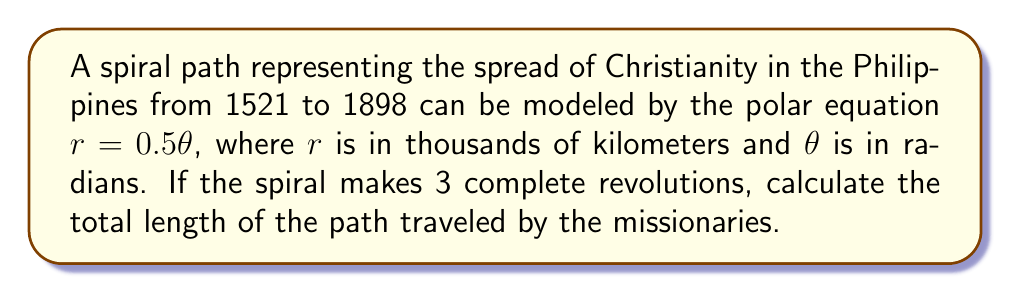Can you solve this math problem? To solve this problem, we'll follow these steps:

1) First, recall the formula for the arc length of a curve in polar coordinates:

   $$L = \int_a^b \sqrt{r^2 + \left(\frac{dr}{d\theta}\right)^2} d\theta$$

2) For our spiral, $r = 0.5\theta$, so $\frac{dr}{d\theta} = 0.5$

3) Substituting these into the formula:

   $$L = \int_a^b \sqrt{(0.5\theta)^2 + (0.5)^2} d\theta$$

4) Simplify under the square root:

   $$L = \int_a^b \sqrt{0.25\theta^2 + 0.25} d\theta = 0.5\int_a^b \sqrt{\theta^2 + 1} d\theta$$

5) For the limits of integration, we start at $\theta = 0$ and end at $\theta = 6\pi$ (3 complete revolutions)

6) This integral doesn't have an elementary antiderivative, but it can be solved using the hyperbolic sine function:

   $$L = 0.5 \left[\frac{\theta}{2}\sqrt{\theta^2+1} + \frac{1}{2}\ln(\theta + \sqrt{\theta^2+1})\right]_0^{6\pi}$$

7) Evaluating at the limits:

   $$L = 0.5 \left[\frac{6\pi}{2}\sqrt{36\pi^2+1} + \frac{1}{2}\ln(6\pi + \sqrt{36\pi^2+1}) - 0\right]$$

8) Simplifying and calculating (you may use a calculator for this step):

   $$L \approx 56.54843$$

Remember that $r$ was in thousands of kilometers, so our final answer needs to be multiplied by 1000.
Answer: The total length of the spiral path is approximately 56,548 kilometers. 